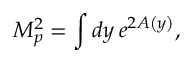Convert formula to latex. <formula><loc_0><loc_0><loc_500><loc_500>M _ { p } ^ { 2 } = \int d y \, e ^ { 2 A \left ( y \right ) } ,</formula> 